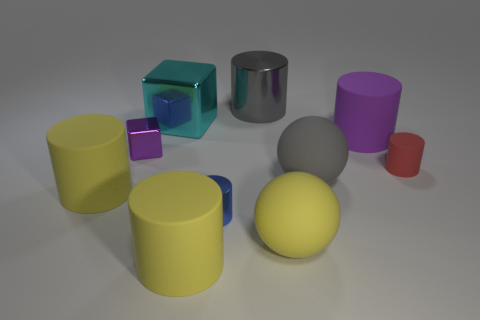Subtract all large cylinders. How many cylinders are left? 2 Subtract all blue cylinders. How many cylinders are left? 5 Subtract all cylinders. How many objects are left? 4 Subtract all red matte blocks. Subtract all large gray objects. How many objects are left? 8 Add 9 purple matte objects. How many purple matte objects are left? 10 Add 5 large cyan blocks. How many large cyan blocks exist? 6 Subtract 0 green spheres. How many objects are left? 10 Subtract 1 cylinders. How many cylinders are left? 5 Subtract all purple cylinders. Subtract all yellow spheres. How many cylinders are left? 5 Subtract all red spheres. How many yellow cylinders are left? 2 